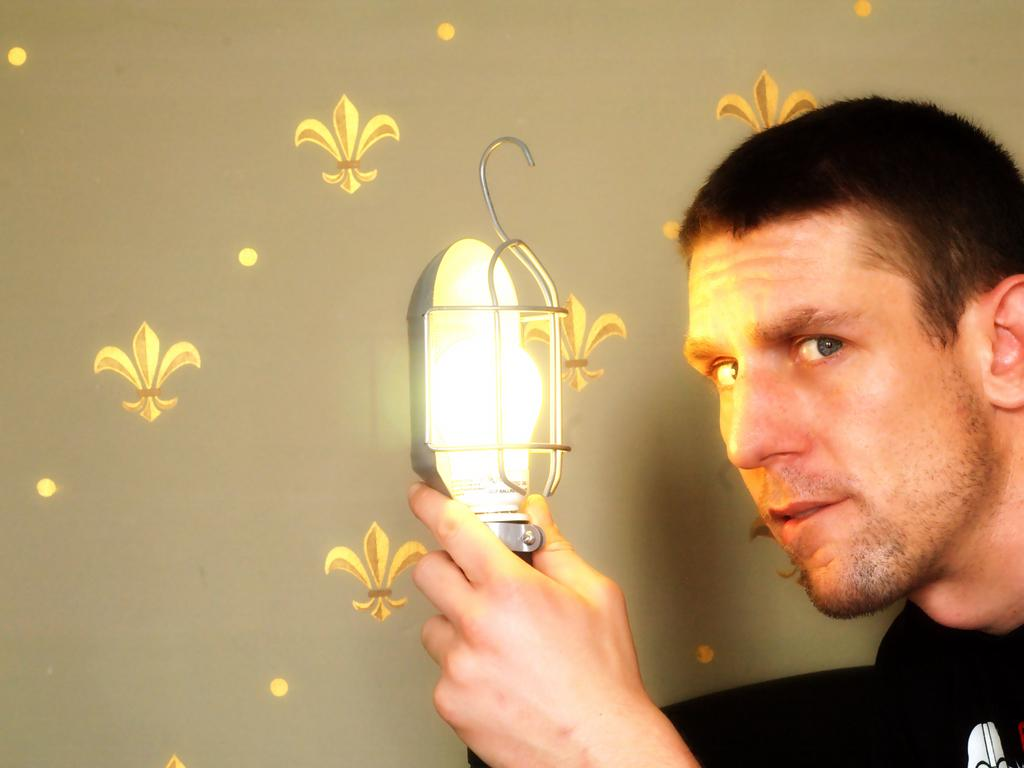Who is present in the image? There is a man in the image. What is the man holding in the image? The man is holding a light. What can be seen in the background of the image? There is a wall in the background of the image. Can you describe the wall in the image? There is a design on the wall. Where is the nearest hydrant to the man in the image? There is no hydrant visible in the image, so it cannot be determined where the nearest one is. 